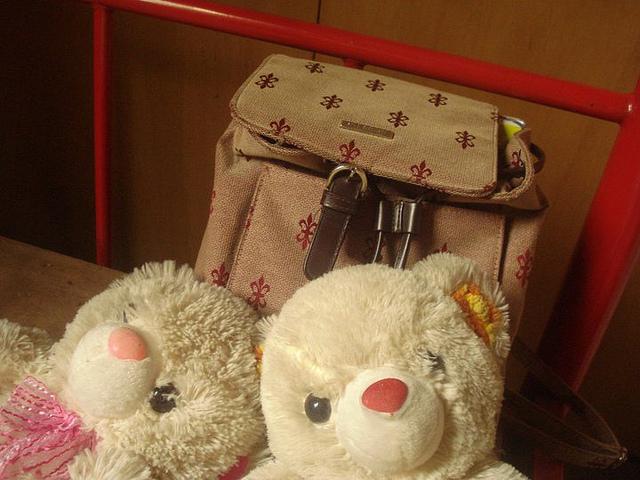How many stuffed animals are there?
Answer briefly. 2. How many white bears are in this scene?
Short answer required. 2. What color is the bow on the bear?
Give a very brief answer. Pink. What color is on the inside of the right bear's ear?
Concise answer only. Yellow. 